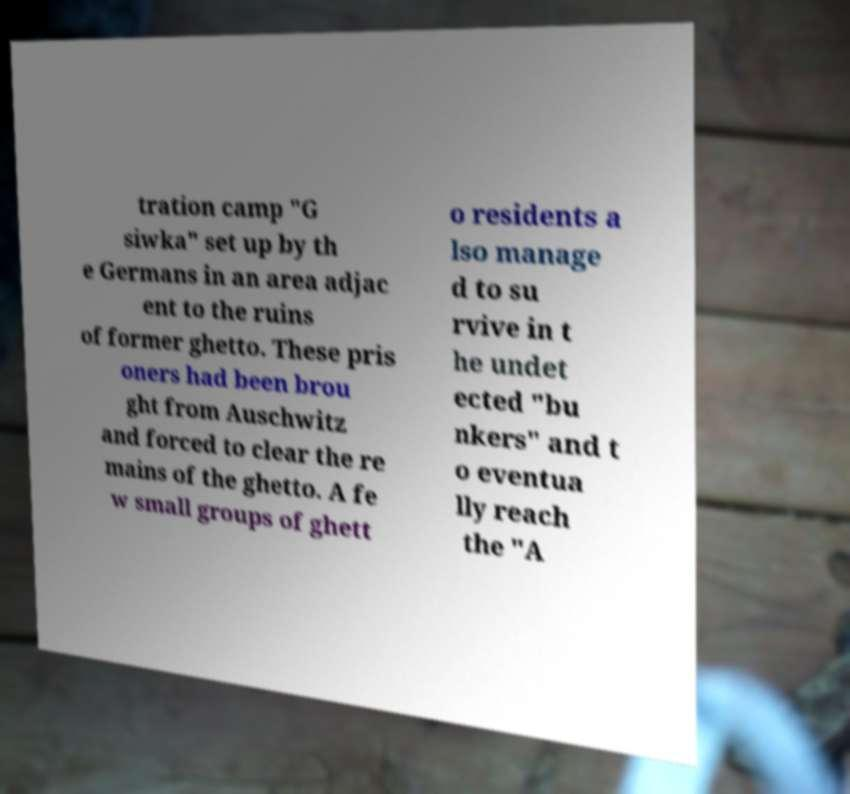I need the written content from this picture converted into text. Can you do that? tration camp "G siwka" set up by th e Germans in an area adjac ent to the ruins of former ghetto. These pris oners had been brou ght from Auschwitz and forced to clear the re mains of the ghetto. A fe w small groups of ghett o residents a lso manage d to su rvive in t he undet ected "bu nkers" and t o eventua lly reach the "A 